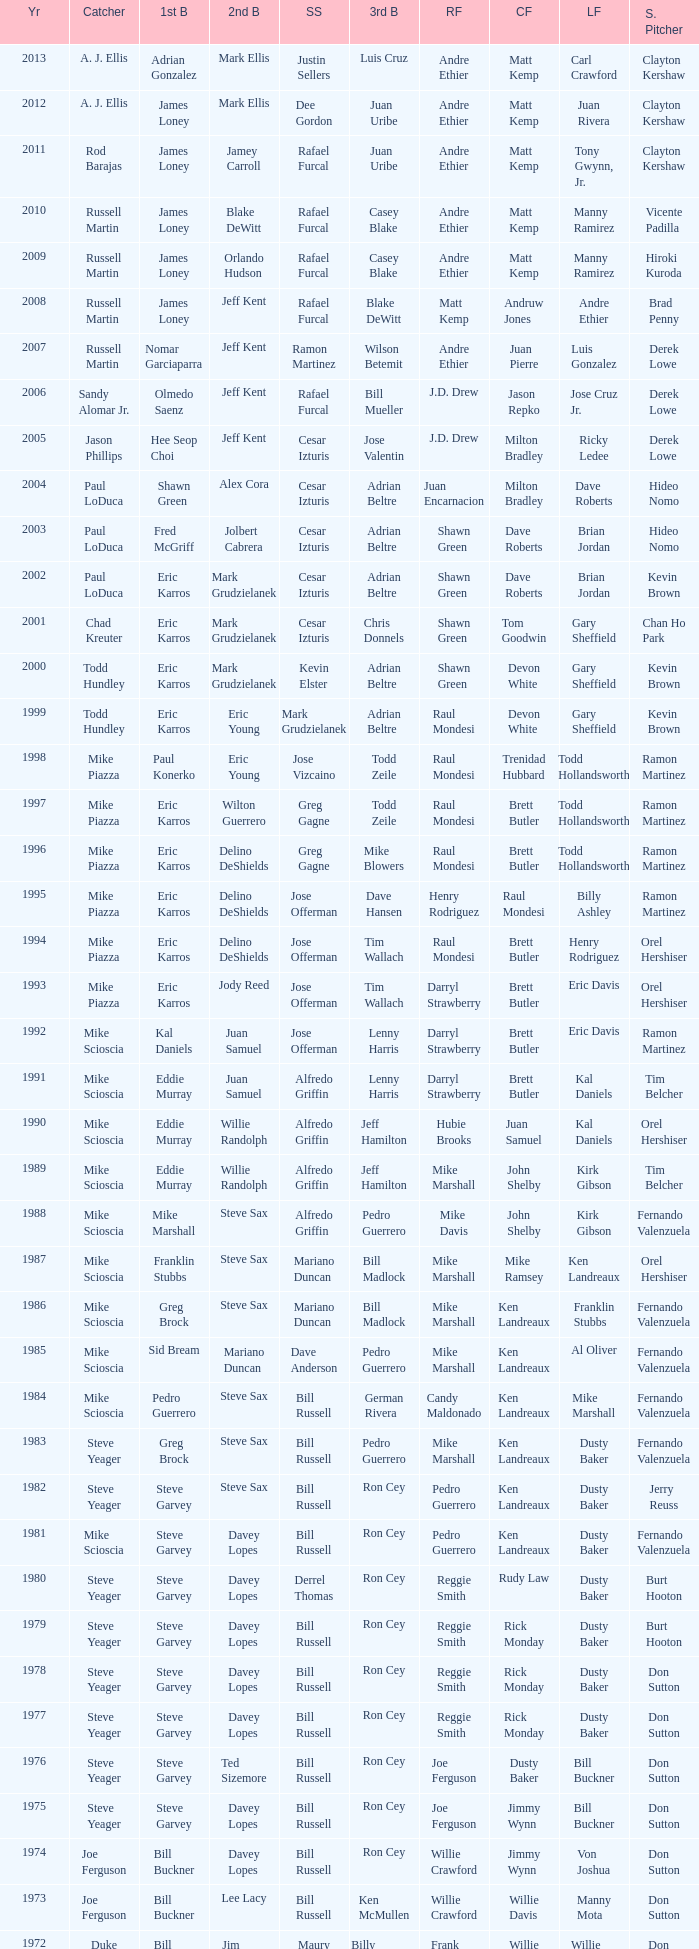Who played 2nd base when nomar garciaparra was at 1st base? Jeff Kent. 